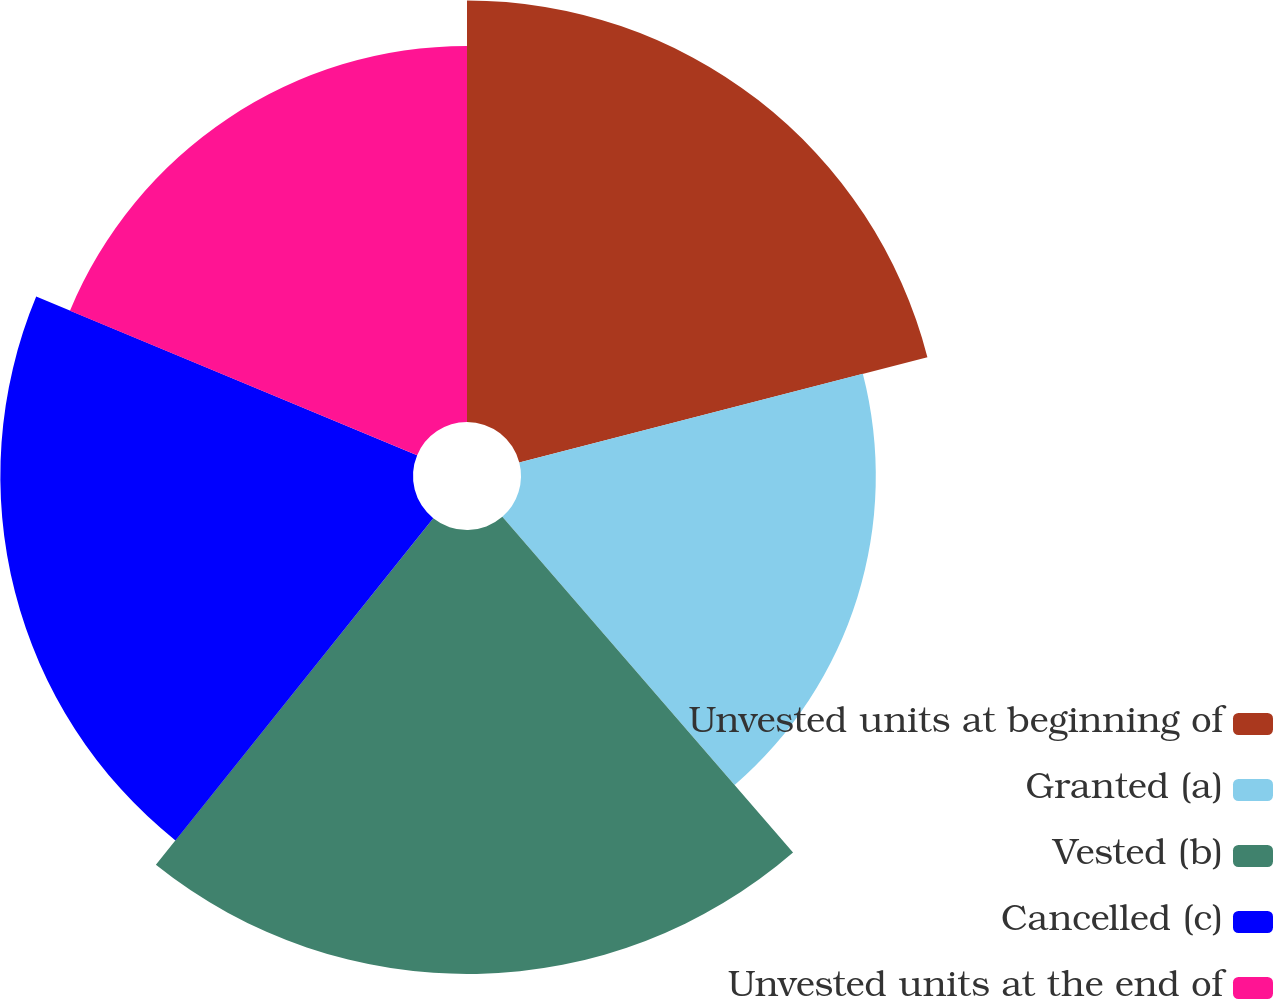Convert chart. <chart><loc_0><loc_0><loc_500><loc_500><pie_chart><fcel>Unvested units at beginning of<fcel>Granted (a)<fcel>Vested (b)<fcel>Cancelled (c)<fcel>Unvested units at the end of<nl><fcel>20.98%<fcel>17.66%<fcel>22.1%<fcel>20.54%<fcel>18.72%<nl></chart> 